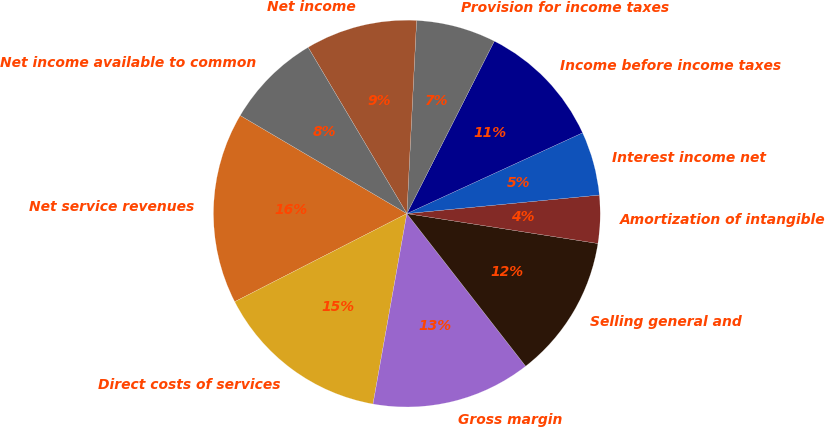<chart> <loc_0><loc_0><loc_500><loc_500><pie_chart><fcel>Net service revenues<fcel>Direct costs of services<fcel>Gross margin<fcel>Selling general and<fcel>Amortization of intangible<fcel>Interest income net<fcel>Income before income taxes<fcel>Provision for income taxes<fcel>Net income<fcel>Net income available to common<nl><fcel>16.0%<fcel>14.67%<fcel>13.33%<fcel>12.0%<fcel>4.0%<fcel>5.33%<fcel>10.67%<fcel>6.67%<fcel>9.33%<fcel>8.0%<nl></chart> 